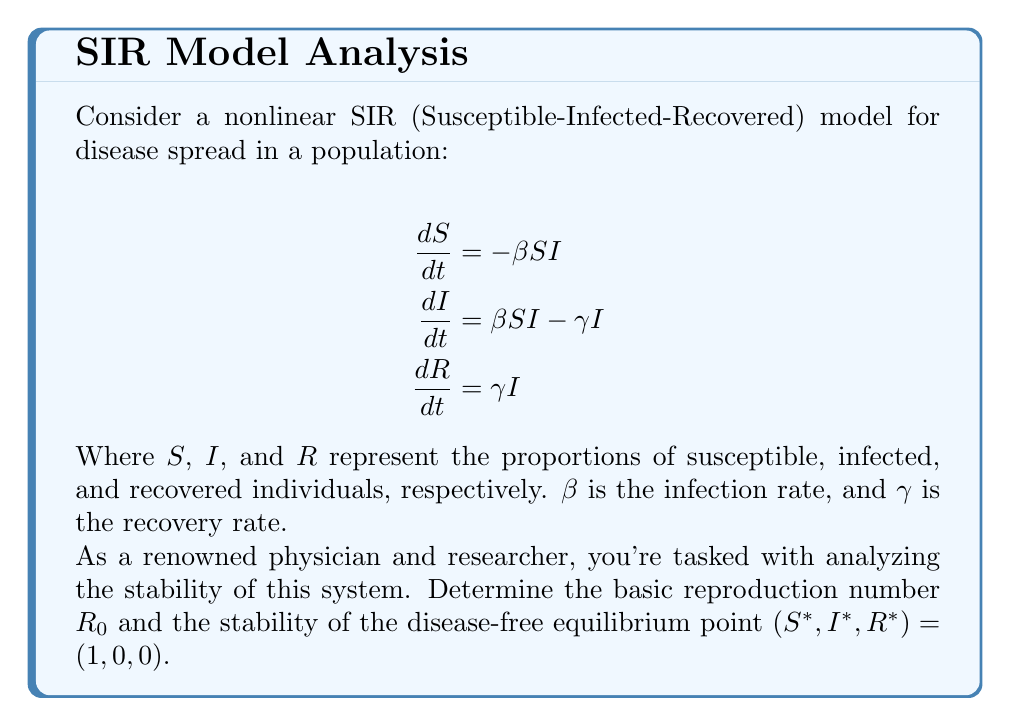What is the answer to this math problem? To analyze the stability of the disease-free equilibrium (DFE), we'll follow these steps:

1) First, calculate the basic reproduction number $R_0$:
   $R_0 = \frac{\beta}{\gamma}$

2) At the DFE $(1, 0, 0)$, we need to analyze the behavior of $I$:
   $$\frac{dI}{dt} = \beta SI - \gamma I = (\beta S - \gamma)I$$

3) At the DFE, $S = 1$, so:
   $$\frac{dI}{dt} = (\beta - \gamma)I = \gamma(\frac{\beta}{\gamma} - 1)I = \gamma(R_0 - 1)I$$

4) The stability of the DFE depends on the sign of $(R_0 - 1)$:

   - If $R_0 < 1$, then $\frac{dI}{dt} < 0$ near the DFE, so $I$ decreases and the DFE is stable.
   - If $R_0 > 1$, then $\frac{dI}{dt} > 0$ near the DFE, so $I$ increases and the DFE is unstable.
   - If $R_0 = 1$, it's a critical case and further analysis would be needed.

5) To rigorously prove stability, we would compute the Jacobian matrix at the DFE:

   $$J = \begin{bmatrix}
   -\beta I & -\beta S & 0 \\
   \beta I & \beta S - \gamma & 0 \\
   0 & \gamma & 0
   \end{bmatrix}$$

   At the DFE $(1, 0, 0)$:

   $$J_{DFE} = \begin{bmatrix}
   0 & -\beta & 0 \\
   0 & \beta - \gamma & 0 \\
   0 & \gamma & 0
   \end{bmatrix}$$

6) The eigenvalues of $J_{DFE}$ are $\lambda_1 = 0$, $\lambda_2 = \beta - \gamma = \gamma(R_0 - 1)$, and $\lambda_3 = 0$.

   The DFE is stable if all eigenvalues have non-positive real parts, which occurs when $R_0 \leq 1$.

Therefore, the stability of the DFE depends on the value of $R_0$:
- If $R_0 < 1$, the DFE is asymptotically stable.
- If $R_0 > 1$, the DFE is unstable.
- If $R_0 = 1$, the DFE is neutrally stable (further analysis needed for nonlinear stability).
Answer: The basic reproduction number is $R_0 = \frac{\beta}{\gamma}$. The disease-free equilibrium $(1, 0, 0)$ is stable if $R_0 < 1$, unstable if $R_0 > 1$, and neutrally stable if $R_0 = 1$. 